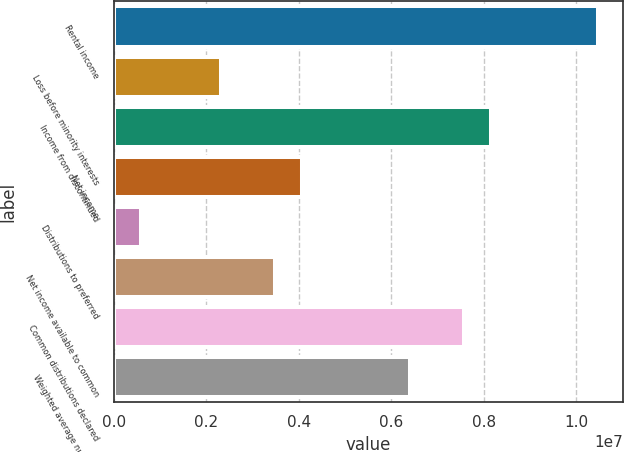Convert chart. <chart><loc_0><loc_0><loc_500><loc_500><bar_chart><fcel>Rental income<fcel>Loss before minority interests<fcel>Income from discontinued<fcel>Net income<fcel>Distributions to preferred<fcel>Net income available to common<fcel>Common distributions declared<fcel>Weighted average number of<nl><fcel>1.04762e+07<fcel>2.32805e+06<fcel>8.14817e+06<fcel>4.07409e+06<fcel>582013<fcel>3.49207e+06<fcel>7.56616e+06<fcel>6.40213e+06<nl></chart> 